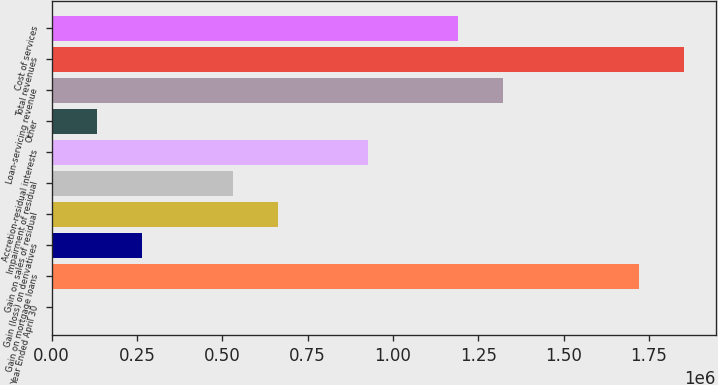<chart> <loc_0><loc_0><loc_500><loc_500><bar_chart><fcel>Year Ended April 30<fcel>Gain on mortgage loans<fcel>Gain (loss) on derivatives<fcel>Gain on sales of residual<fcel>Impairment of residual<fcel>Accretion-residual interests<fcel>Other<fcel>Loan-servicing revenue<fcel>Total revenues<fcel>Cost of services<nl><fcel>2004<fcel>1.72022e+06<fcel>266345<fcel>662856<fcel>530686<fcel>927198<fcel>134174<fcel>1.32371e+06<fcel>1.85239e+06<fcel>1.19154e+06<nl></chart> 